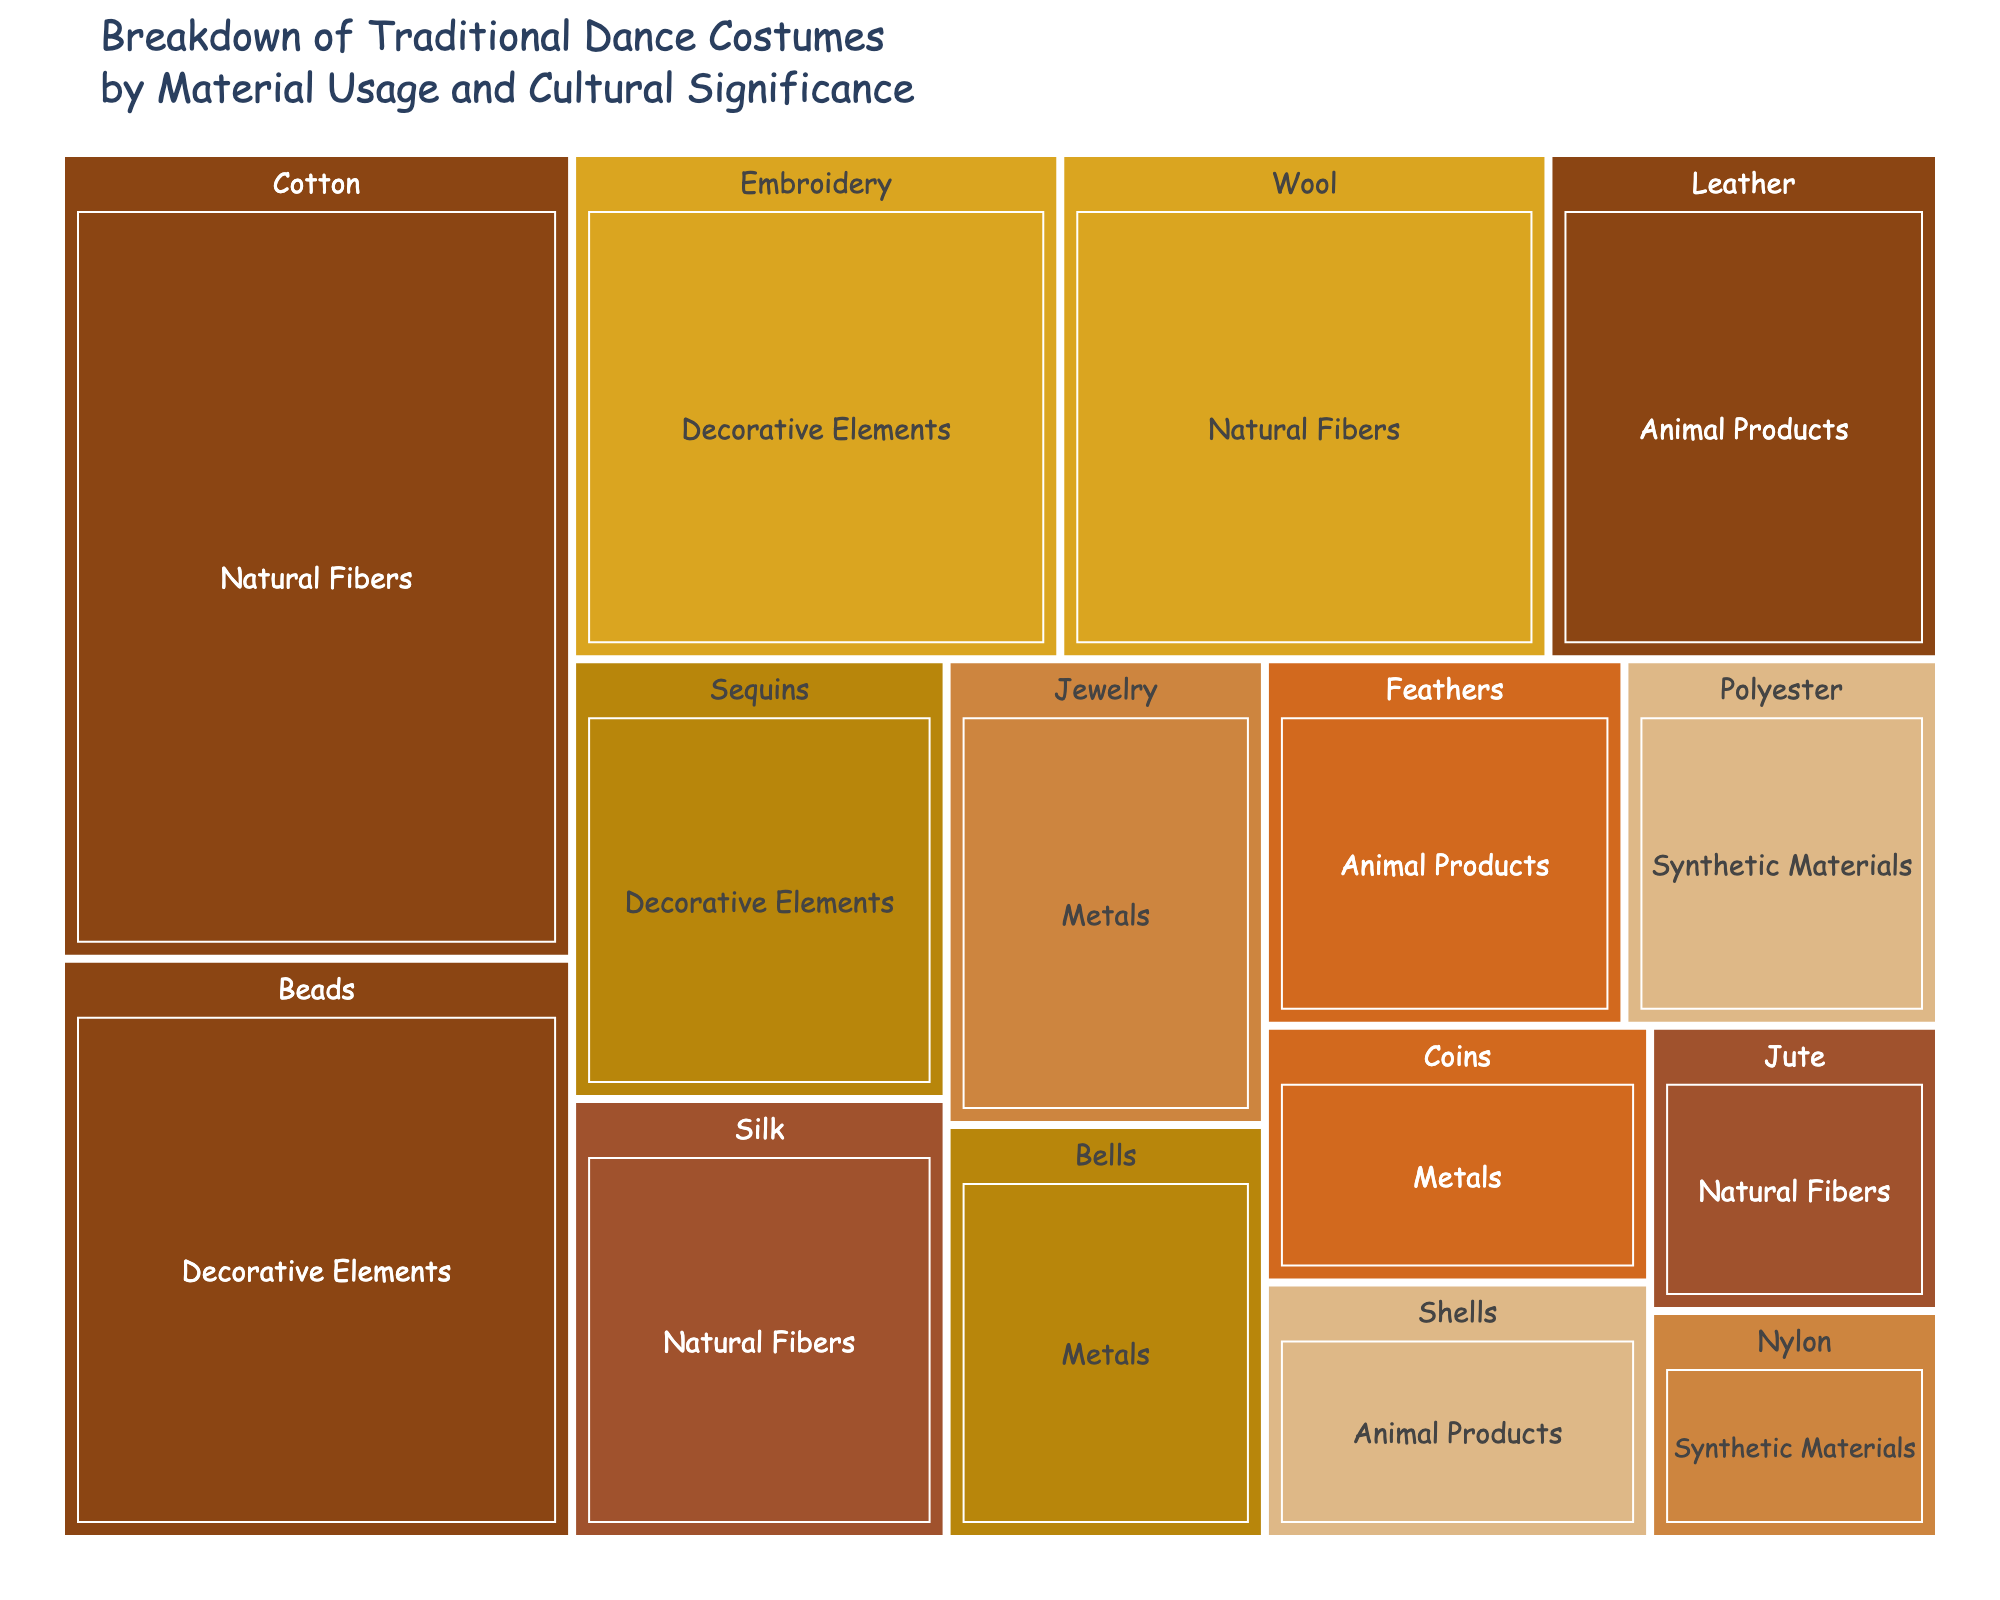How many categories of materials are shown in the treemap? The treemap displays a parent node for each material category, such as "Natural Fibers," "Animal Products," "Synthetic Materials," "Decorative Elements," and "Metals." Count these parent nodes.
Answer: 5 Which material has the highest usage among Natural Fibers? In the Natural Fibers category, observe the size of each rectangle. The largest rectangle represents the material with the highest usage.
Answer: Cotton What is the combined usage percentage of Animal Products? Sum the usage percentages of all materials under the Animal Products category: Leather (12%), Feathers (8%), and Shells (6%).
Answer: 26% Which two materials have equal usage? Identify the two rectangles that are the same size. Beads and Embroidery both have equal usage.
Answer: Beads and Embroidery Which category has the lowest aggregate usage? Calculate the total usage for each category and compare the results. Synthetic Materials sums to 11%, which is the lowest aggregate.
Answer: Synthetic Materials Is the usage of Feathers greater or less than Embroidery? Compare their usage values. Feathers have 8% usage, while Embroidery has 15%.
Answer: Less What is the percentage difference between the highest and lowest usage within Metal materials? Identify the highest and lowest values in Metals: Jewelry (9%) and Coins (6%). Then subtract the smallest from the largest: 9% - 6%.
Answer: 3% Which category contains the most diverse range of materials? Observe the number of unique materials in each category. Natural Fibers have the most materials: Cotton, Wool, Silk, Jute.
Answer: Natural Fibers What is the combined usage of Beads and Sequins? Add the usage percentages for Beads (18%) and Sequins (10%).
Answer: 28% Which material has the lowest usage, and under what category does it fall? Identify the smallest rectangle in the treemap. Jute has 5% usage, and it falls under Natural Fibers.
Answer: Jute, Natural Fibers 